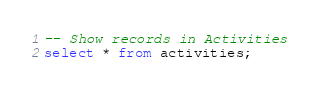<code> <loc_0><loc_0><loc_500><loc_500><_SQL_>-- Show records in Activities
select * from activities;

</code> 